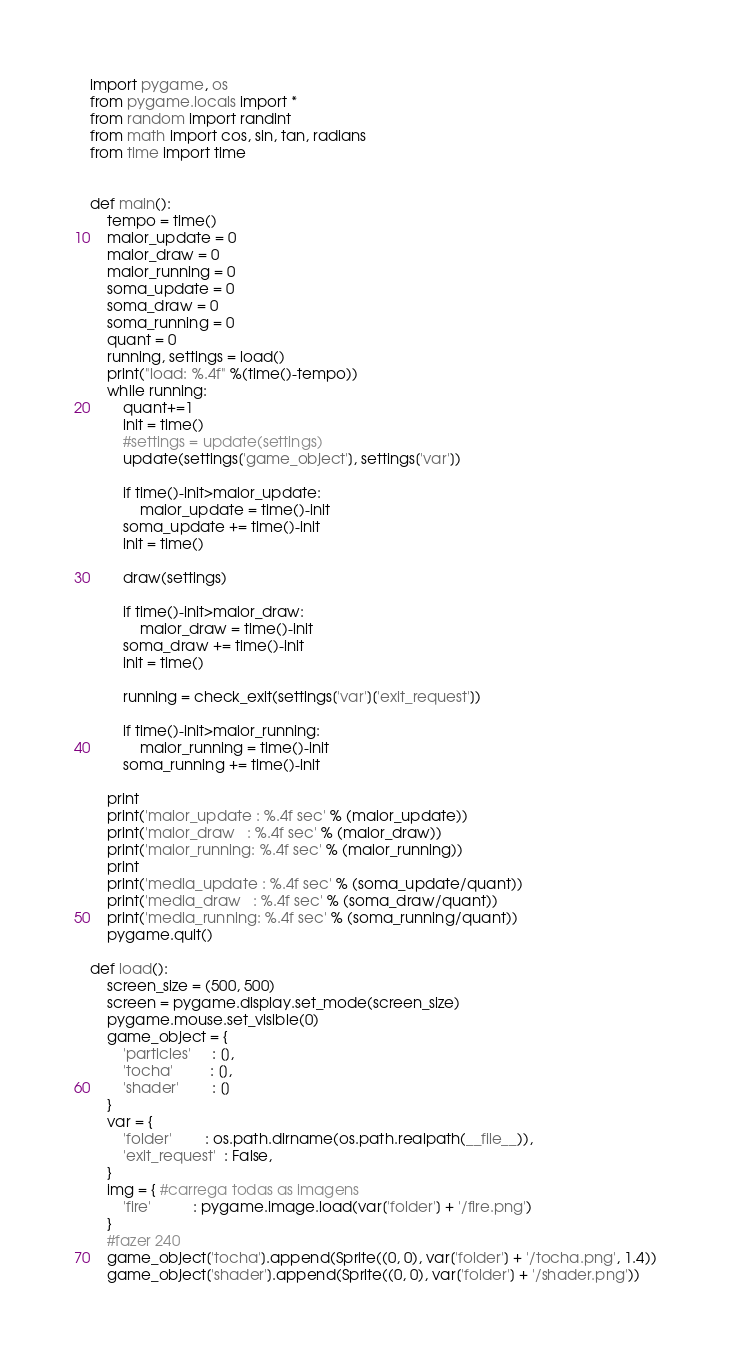Convert code to text. <code><loc_0><loc_0><loc_500><loc_500><_Python_>import pygame, os
from pygame.locals import *
from random import randint
from math import cos, sin, tan, radians
from time import time


def main():
    tempo = time()
    maior_update = 0
    maior_draw = 0
    maior_running = 0
    soma_update = 0
    soma_draw = 0
    soma_running = 0
    quant = 0
    running, settings = load()
    print("load: %.4f" %(time()-tempo))
    while running:
        quant+=1
        init = time()
        #settings = update(settings)
        update(settings['game_object'], settings['var'])

        if time()-init>maior_update:
            maior_update = time()-init
        soma_update += time()-init
        init = time()

        draw(settings)

        if time()-init>maior_draw:
            maior_draw = time()-init
        soma_draw += time()-init
        init = time()

        running = check_exit(settings['var']['exit_request'])

        if time()-init>maior_running:
            maior_running = time()-init
        soma_running += time()-init
    
    print
    print('maior_update : %.4f sec' % (maior_update))
    print('maior_draw   : %.4f sec' % (maior_draw))
    print('maior_running: %.4f sec' % (maior_running))
    print
    print('media_update : %.4f sec' % (soma_update/quant))
    print('media_draw   : %.4f sec' % (soma_draw/quant))
    print('media_running: %.4f sec' % (soma_running/quant))
    pygame.quit()

def load():
    screen_size = (500, 500)
    screen = pygame.display.set_mode(screen_size)
    pygame.mouse.set_visible(0)
    game_object = {
        'particles'     : [],
        'tocha'         : [],
        'shader'        : []
    }
    var = {
        'folder'        : os.path.dirname(os.path.realpath(__file__)),
        'exit_request'  : False,
    }
    img = { #carrega todas as imagens
        'fire'          : pygame.image.load(var['folder'] + '/fire.png')
    }
    #fazer 240
    game_object['tocha'].append(Sprite((0, 0), var['folder'] + '/tocha.png', 1.4))
    game_object['shader'].append(Sprite((0, 0), var['folder'] + '/shader.png'))</code> 